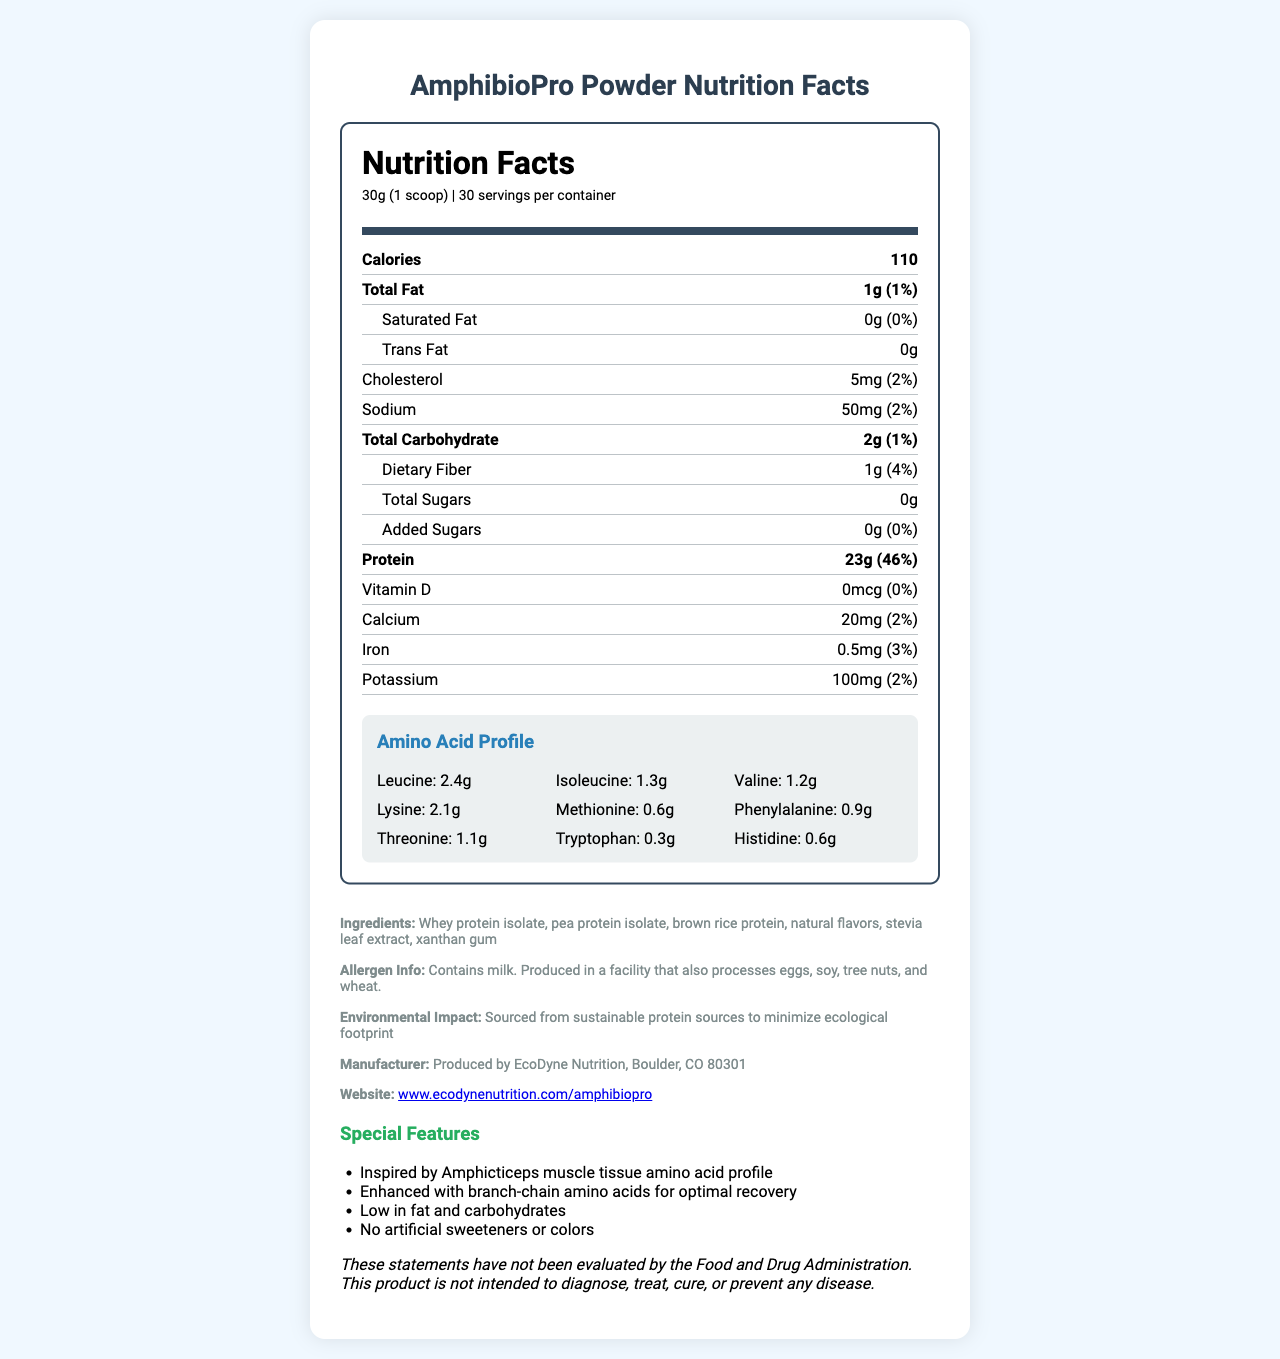what is the serving size of AmphibioPro Powder? The serving size is stated in the document as "30g (1 scoop)".
Answer: 30g (1 scoop) how many servings are there in a container of AmphibioPro Powder? The document mentions that there are 30 servings per container.
Answer: 30 how many calories are in each serving of AmphibioPro Powder? Each serving contains 110 calories, which is clearly stated in the document.
Answer: 110 what are the main sources of protein in AmphibioPro Powder? The ingredients list includes these protein sources.
Answer: Whey protein isolate, pea protein isolate, brown rice protein what is the amount of leucine per serving in AmphibioPro Powder? The Amino Acid Profile section specifies that there are 2.4g of leucine per serving.
Answer: 2.4g what is the percentage daily value of protein per serving? The summary under protein states that it provides 46% of the daily value per serving.
Answer: 46% Which amino acid in AmphibioPro Powder has the lowest amount per serving? A. Leucine B. Methionine C. Tryptophan D. Valine The document shows that tryptophan has 0.3g per serving, which is the lowest amount.
Answer: C. Tryptophan Which option correctly describes the total carbohydrates content per serving? I. 1g dietary fiber and 1g total sugars II. 2g dietary fiber and 1g added sugars III. 1g dietary fiber and 0g total sugars IV. 1g dietary fiber and 1g added sugars The document states that there are 2g of total carbohydrates, with 1g of dietary fiber and 0g of total sugars.
Answer: III. 1g dietary fiber and 0g total sugars does AmphibioPro Powder contain any added sugars? The nutritional information states "Added Sugars: 0g (0%)".
Answer: No summarize the main idea of the document. The document provides detailed nutritional information about AmphibioPro Powder, including calorie content, macronutrients, micronutrients, amino acid profile, ingredients, and special features. It highlights its inspiration from Amphicticeps muscle tissue, its health benefits, and environmental consciousness.
Answer: AmphibioPro Powder is a human-grade protein powder inspired by the amino acid profile of Amphicticeps muscle tissue. It features a balanced nutrient profile with low fat and carbohydrates, and is designed for optimal recovery with additional branch-chain amino acids. It is environmentally friendly and made from sustainable protein sources, containing no artificial sweeteners or colors. The product is manufactured by EcoDyne Nutrition and provides complete nutritional information, including allergen warnings. what is the manufacturer’s location for AmphibioPro Powder? The manufacturer information section indicates that it is produced by EcoDyne Nutrition in Boulder, CO 80301.
Answer: Boulder, CO 80301 how can one access more information about AmphibioPro Powder online? The document provides a web link for more information about the product.
Answer: www.ecodynenutrition.com/amphibiopro which amino acids are present in equal amounts in AmphibioPro Powder? The document lists both methionine and histidine as having 0.6g per serving.
Answer: Methionine and Histidine what is the environmental impact of AmphibioPro Powder? The document mentions that the product is sourced from sustainable protein sources to minimize its ecological footprint.
Answer: Sourced from sustainable protein sources to minimize ecological footprint is AmphibioPro Powder suitable for someone with a tree nuts allergy? The document says it is produced in a facility that processes tree nuts, posing a risk for individuals with a tree nuts allergy.
Answer: No does AmphibioPro Powder contain any artificial sweeteners or colors? The special features section states that it contains no artificial sweeteners or colors.
Answer: No what special features make AmphibioPro Powder unique? The special features section lists these unique attributes.
Answer: It is inspired by Amphicticeps muscle tissue amino acid profile, enhanced with branch-chain amino acids for optimal recovery, low in fat and carbohydrates, and contains no artificial sweeteners or colors. 